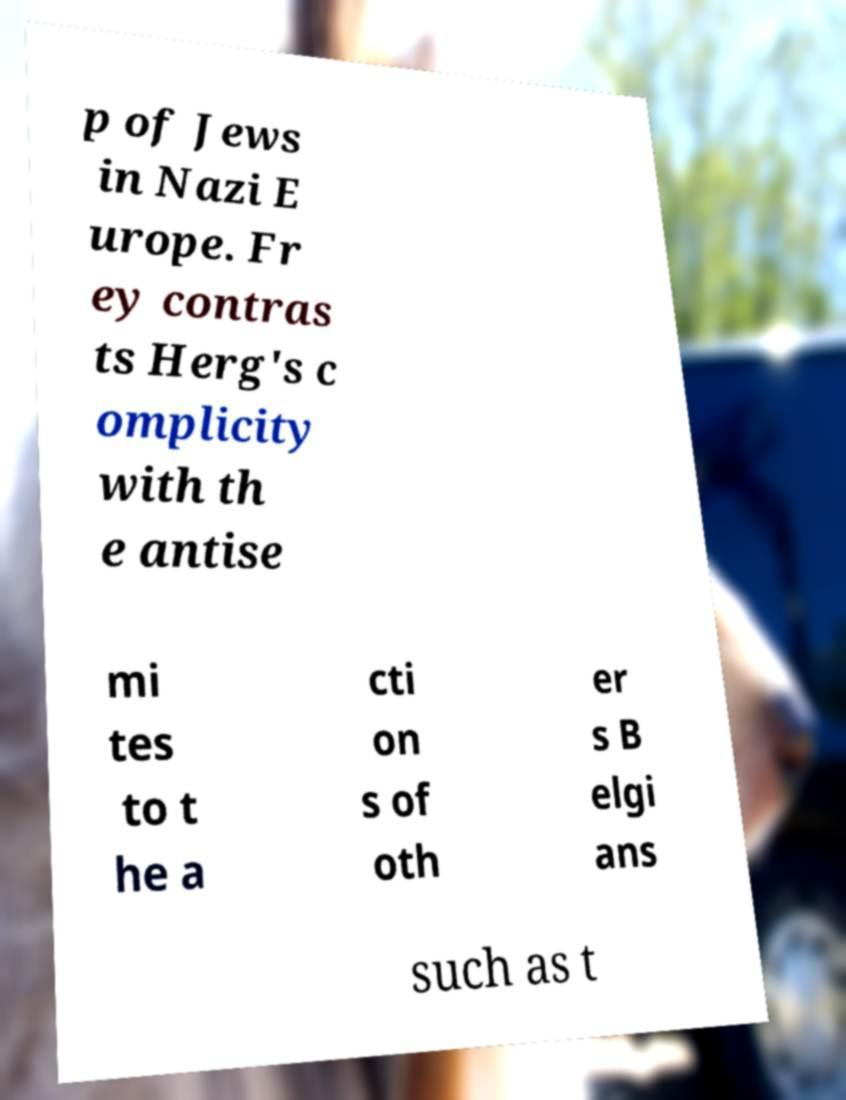There's text embedded in this image that I need extracted. Can you transcribe it verbatim? p of Jews in Nazi E urope. Fr ey contras ts Herg's c omplicity with th e antise mi tes to t he a cti on s of oth er s B elgi ans such as t 